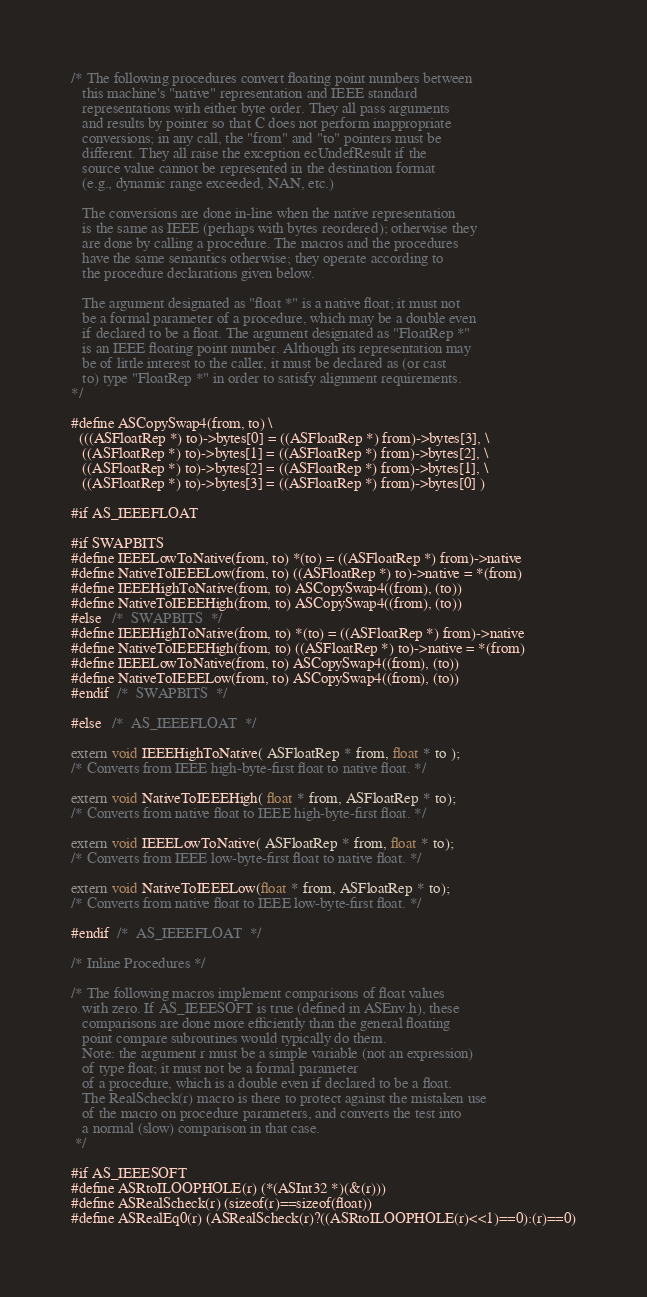<code> <loc_0><loc_0><loc_500><loc_500><_C_>
/* The following procedures convert floating point numbers between
   this machine's "native" representation and IEEE standard
   representations with either byte order. They all pass arguments
   and results by pointer so that C does not perform inappropriate
   conversions; in any call, the "from" and "to" pointers must be
   different. They all raise the exception ecUndefResult if the
   source value cannot be represented in the destination format
   (e.g., dynamic range exceeded, NAN, etc.)

   The conversions are done in-line when the native representation
   is the same as IEEE (perhaps with bytes reordered); otherwise they
   are done by calling a procedure. The macros and the procedures
   have the same semantics otherwise; they operate according to
   the procedure declarations given below.

   The argument designated as "float *" is a native float; it must not
   be a formal parameter of a procedure, which may be a double even
   if declared to be a float. The argument designated as "FloatRep *"
   is an IEEE floating point number. Although its representation may
   be of little interest to the caller, it must be declared as (or cast
   to) type "FloatRep *" in order to satisfy alignment requirements.
*/

#define ASCopySwap4(from, to) \
  (((ASFloatRep *) to)->bytes[0] = ((ASFloatRep *) from)->bytes[3], \
   ((ASFloatRep *) to)->bytes[1] = ((ASFloatRep *) from)->bytes[2], \
   ((ASFloatRep *) to)->bytes[2] = ((ASFloatRep *) from)->bytes[1], \
   ((ASFloatRep *) to)->bytes[3] = ((ASFloatRep *) from)->bytes[0] )

#if AS_IEEEFLOAT

#if SWAPBITS
#define IEEELowToNative(from, to) *(to) = ((ASFloatRep *) from)->native
#define NativeToIEEELow(from, to) ((ASFloatRep *) to)->native = *(from)
#define IEEEHighToNative(from, to) ASCopySwap4((from), (to))
#define NativeToIEEEHigh(from, to) ASCopySwap4((from), (to))
#else   /*  SWAPBITS  */
#define IEEEHighToNative(from, to) *(to) = ((ASFloatRep *) from)->native
#define NativeToIEEEHigh(from, to) ((ASFloatRep *) to)->native = *(from)
#define IEEELowToNative(from, to) ASCopySwap4((from), (to))
#define NativeToIEEELow(from, to) ASCopySwap4((from), (to))
#endif  /*  SWAPBITS  */

#else   /*  AS_IEEEFLOAT  */

extern void IEEEHighToNative( ASFloatRep * from, float * to );
/* Converts from IEEE high-byte-first float to native float. */

extern void NativeToIEEEHigh( float * from, ASFloatRep * to);
/* Converts from native float to IEEE high-byte-first float. */

extern void IEEELowToNative( ASFloatRep * from, float * to);
/* Converts from IEEE low-byte-first float to native float. */

extern void NativeToIEEELow(float * from, ASFloatRep * to);
/* Converts from native float to IEEE low-byte-first float. */

#endif  /*  AS_IEEEFLOAT  */

/* Inline Procedures */

/* The following macros implement comparisons of float values
   with zero. If AS_IEEESOFT is true (defined in ASEnv.h), these
   comparisons are done more efficiently than the general floating
   point compare subroutines would typically do them.
   Note: the argument r must be a simple variable (not an expression)
   of type float; it must not be a formal parameter
   of a procedure, which is a double even if declared to be a float.
   The RealScheck(r) macro is there to protect against the mistaken use
   of the macro on procedure parameters, and converts the test into
   a normal (slow) comparison in that case.
 */

#if AS_IEEESOFT
#define ASRtoILOOPHOLE(r) (*(ASInt32 *)(&(r)))
#define ASRealScheck(r) (sizeof(r)==sizeof(float))
#define ASRealEq0(r) (ASRealScheck(r)?((ASRtoILOOPHOLE(r)<<1)==0):(r)==0)</code> 